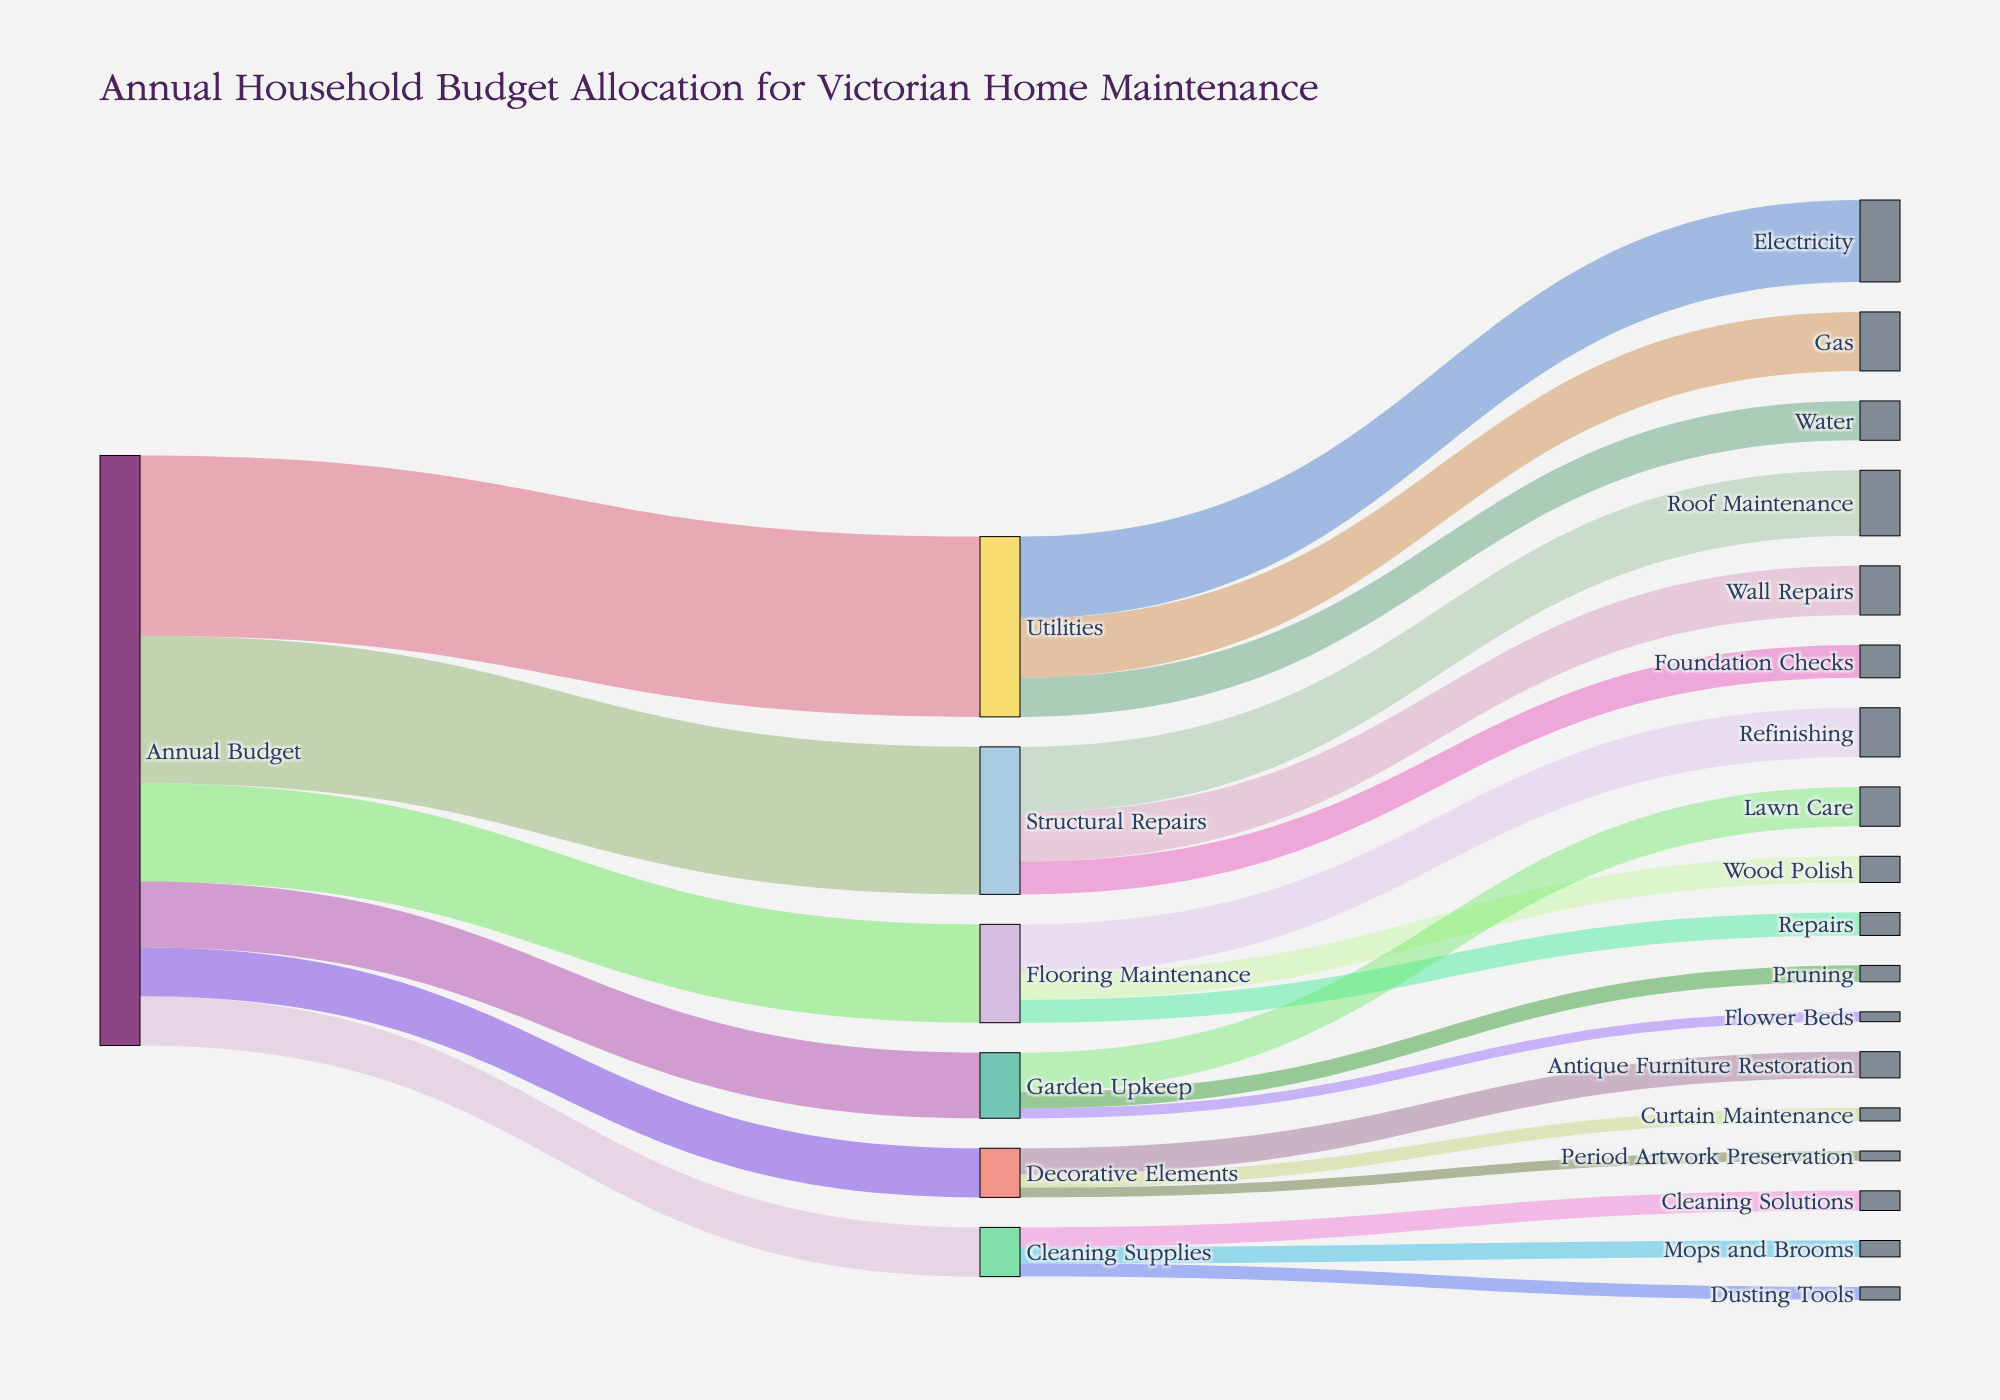What's the total annual budget allocated for maintaining the Victorian home? To find the total annual budget allocation, sum up all the values starting from 'Annual Budget' to each category. That includes Flooring Maintenance (3000), Structural Repairs (4500), Utilities (5500), Cleaning Supplies (1500), Garden Upkeep (2000), and Decorative Elements (1500). So, the total is 3000 + 4500 + 5500 + 1500 + 2000 + 1500 = 18000.
Answer: 18000 Which category receives the highest portion of the annual budget? The category with the highest value connected from 'Annual Budget' will be the one receiving the highest portion. The values are Flooring Maintenance (3000), Structural Repairs (4500), Utilities (5500), Cleaning Supplies (1500), Garden Upkeep (2000), and Decorative Elements (1500). The highest is 5500 for Utilities.
Answer: Utilities How much is allocated to Refinishing under Flooring Maintenance? Follow the link from 'Flooring Maintenance' to its subcategories. Refinishing has an allocation of 1500.
Answer: 1500 Compare the budget allocated between Roof Maintenance and Wall Repairs under Structural Repairs. Which one receives more, and by how much? Roof Maintenance gets 2000, and Wall Repairs gets 1500. The difference is 2000 - 1500 = 500. Roof Maintenance receives 500 more than Wall Repairs.
Answer: Roof Maintenance, 500 What's the sum of budgets allocated to all subcategories under Garden Upkeep? Add up the allocations for Lawn Care (1200), Pruning (500), and Flower Beds (300). The total is 1200 + 500 + 300 = 2000.
Answer: 2000 Which subcategory within Utilities has the lowest budget allocation and what is the amount? Analyze the values under Utilities: Electricity (2500), Gas (1800), Water (1200). The lowest is Water with 1200.
Answer: Water, 1200 How much is spent on Dusting Tools compared to Mops and Brooms in Cleaning Supplies? Dusting Tools receive 400, and Mops and Brooms receive 500. Hence, Dusting Tools get 100 less than Mops and Brooms.
Answer: 100 less What percentage of the Flooring Maintenance budget is utilized for Refinishing? Flooring Maintenance totals 3000, Refinishing is 1500. The percentage is (1500 / 3000) * 100 = 50%.
Answer: 50% Is the budget allocated for Period Artwork Preservation more than for Curtain Maintenance under Decorative Elements? Period Artwork Preservation has 300, and Curtain Maintenance has 400. So, no, it is not more.
Answer: No Which element in Cleaning Supplies receives the highest portion of the budget? The subcategories are Dusting Tools (400), Cleaning Solutions (600), and Mops and Brooms (500). Cleaning Solutions receive the highest with 600.
Answer: Cleaning Solutions 